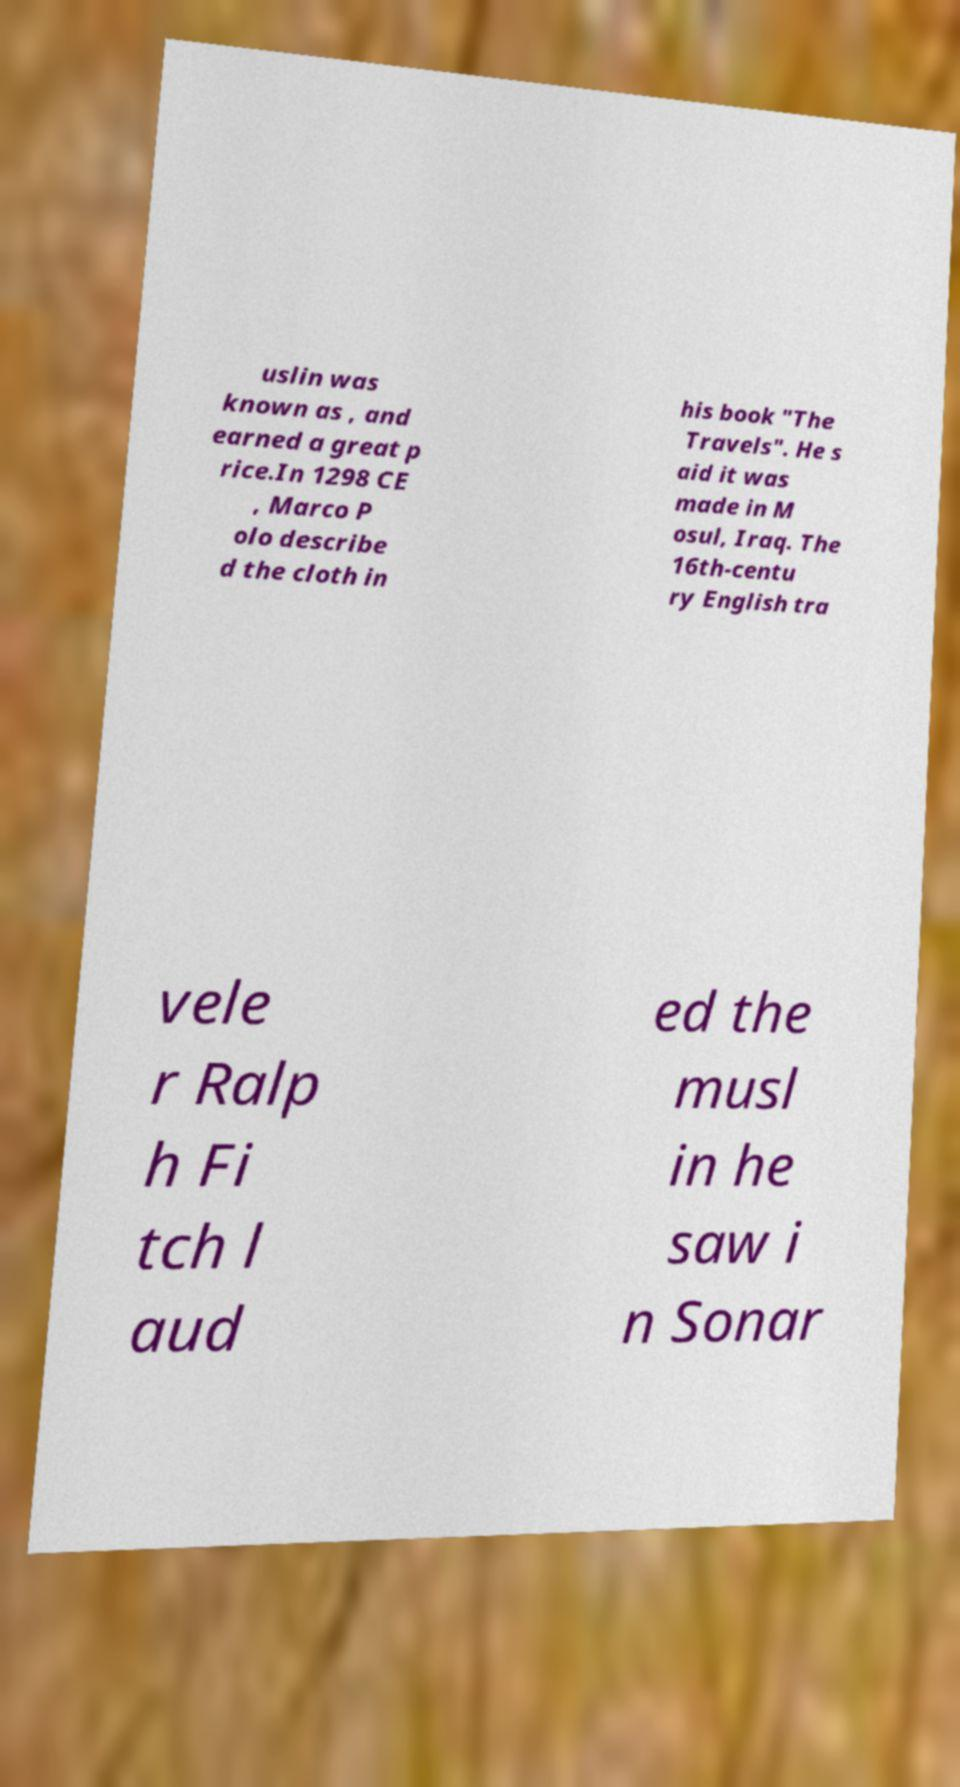Please identify and transcribe the text found in this image. uslin was known as , and earned a great p rice.In 1298 CE , Marco P olo describe d the cloth in his book "The Travels". He s aid it was made in M osul, Iraq. The 16th-centu ry English tra vele r Ralp h Fi tch l aud ed the musl in he saw i n Sonar 